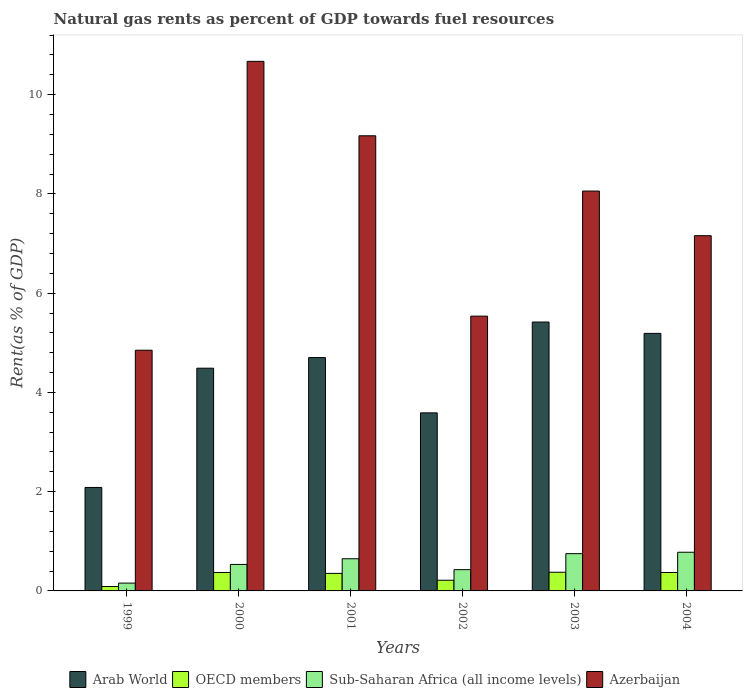How many different coloured bars are there?
Provide a succinct answer. 4. How many groups of bars are there?
Offer a terse response. 6. How many bars are there on the 1st tick from the left?
Ensure brevity in your answer.  4. How many bars are there on the 3rd tick from the right?
Your answer should be compact. 4. In how many cases, is the number of bars for a given year not equal to the number of legend labels?
Your answer should be compact. 0. What is the matural gas rent in Sub-Saharan Africa (all income levels) in 2001?
Make the answer very short. 0.65. Across all years, what is the maximum matural gas rent in Sub-Saharan Africa (all income levels)?
Make the answer very short. 0.78. Across all years, what is the minimum matural gas rent in OECD members?
Make the answer very short. 0.09. In which year was the matural gas rent in Azerbaijan minimum?
Provide a succinct answer. 1999. What is the total matural gas rent in Azerbaijan in the graph?
Offer a very short reply. 45.45. What is the difference between the matural gas rent in Arab World in 2003 and that in 2004?
Provide a succinct answer. 0.23. What is the difference between the matural gas rent in OECD members in 2003 and the matural gas rent in Sub-Saharan Africa (all income levels) in 2004?
Your response must be concise. -0.4. What is the average matural gas rent in Azerbaijan per year?
Offer a very short reply. 7.57. In the year 2003, what is the difference between the matural gas rent in Azerbaijan and matural gas rent in OECD members?
Make the answer very short. 7.68. In how many years, is the matural gas rent in Azerbaijan greater than 9.6 %?
Ensure brevity in your answer.  1. What is the ratio of the matural gas rent in Sub-Saharan Africa (all income levels) in 2001 to that in 2003?
Make the answer very short. 0.86. Is the matural gas rent in Arab World in 1999 less than that in 2004?
Provide a short and direct response. Yes. What is the difference between the highest and the second highest matural gas rent in Azerbaijan?
Offer a very short reply. 1.5. What is the difference between the highest and the lowest matural gas rent in Sub-Saharan Africa (all income levels)?
Make the answer very short. 0.62. In how many years, is the matural gas rent in OECD members greater than the average matural gas rent in OECD members taken over all years?
Make the answer very short. 4. What does the 1st bar from the left in 2002 represents?
Offer a terse response. Arab World. What does the 2nd bar from the right in 2003 represents?
Ensure brevity in your answer.  Sub-Saharan Africa (all income levels). How many bars are there?
Give a very brief answer. 24. What is the difference between two consecutive major ticks on the Y-axis?
Offer a very short reply. 2. Are the values on the major ticks of Y-axis written in scientific E-notation?
Provide a succinct answer. No. Does the graph contain any zero values?
Offer a very short reply. No. Does the graph contain grids?
Your answer should be compact. No. Where does the legend appear in the graph?
Offer a very short reply. Bottom center. How many legend labels are there?
Provide a succinct answer. 4. What is the title of the graph?
Keep it short and to the point. Natural gas rents as percent of GDP towards fuel resources. What is the label or title of the Y-axis?
Offer a very short reply. Rent(as % of GDP). What is the Rent(as % of GDP) in Arab World in 1999?
Your response must be concise. 2.08. What is the Rent(as % of GDP) of OECD members in 1999?
Provide a short and direct response. 0.09. What is the Rent(as % of GDP) of Sub-Saharan Africa (all income levels) in 1999?
Your answer should be very brief. 0.16. What is the Rent(as % of GDP) of Azerbaijan in 1999?
Your response must be concise. 4.85. What is the Rent(as % of GDP) of Arab World in 2000?
Offer a very short reply. 4.49. What is the Rent(as % of GDP) in OECD members in 2000?
Your answer should be very brief. 0.37. What is the Rent(as % of GDP) of Sub-Saharan Africa (all income levels) in 2000?
Give a very brief answer. 0.53. What is the Rent(as % of GDP) of Azerbaijan in 2000?
Your response must be concise. 10.67. What is the Rent(as % of GDP) of Arab World in 2001?
Make the answer very short. 4.7. What is the Rent(as % of GDP) of OECD members in 2001?
Your response must be concise. 0.35. What is the Rent(as % of GDP) of Sub-Saharan Africa (all income levels) in 2001?
Offer a terse response. 0.65. What is the Rent(as % of GDP) in Azerbaijan in 2001?
Make the answer very short. 9.17. What is the Rent(as % of GDP) of Arab World in 2002?
Offer a terse response. 3.59. What is the Rent(as % of GDP) of OECD members in 2002?
Offer a very short reply. 0.22. What is the Rent(as % of GDP) of Sub-Saharan Africa (all income levels) in 2002?
Your answer should be very brief. 0.43. What is the Rent(as % of GDP) in Azerbaijan in 2002?
Your answer should be very brief. 5.54. What is the Rent(as % of GDP) of Arab World in 2003?
Your response must be concise. 5.42. What is the Rent(as % of GDP) of OECD members in 2003?
Your answer should be very brief. 0.38. What is the Rent(as % of GDP) of Sub-Saharan Africa (all income levels) in 2003?
Keep it short and to the point. 0.75. What is the Rent(as % of GDP) of Azerbaijan in 2003?
Provide a short and direct response. 8.06. What is the Rent(as % of GDP) of Arab World in 2004?
Ensure brevity in your answer.  5.19. What is the Rent(as % of GDP) of OECD members in 2004?
Your answer should be compact. 0.37. What is the Rent(as % of GDP) of Sub-Saharan Africa (all income levels) in 2004?
Make the answer very short. 0.78. What is the Rent(as % of GDP) of Azerbaijan in 2004?
Give a very brief answer. 7.16. Across all years, what is the maximum Rent(as % of GDP) in Arab World?
Your response must be concise. 5.42. Across all years, what is the maximum Rent(as % of GDP) of OECD members?
Provide a succinct answer. 0.38. Across all years, what is the maximum Rent(as % of GDP) of Sub-Saharan Africa (all income levels)?
Your response must be concise. 0.78. Across all years, what is the maximum Rent(as % of GDP) of Azerbaijan?
Keep it short and to the point. 10.67. Across all years, what is the minimum Rent(as % of GDP) of Arab World?
Offer a very short reply. 2.08. Across all years, what is the minimum Rent(as % of GDP) of OECD members?
Make the answer very short. 0.09. Across all years, what is the minimum Rent(as % of GDP) in Sub-Saharan Africa (all income levels)?
Your response must be concise. 0.16. Across all years, what is the minimum Rent(as % of GDP) of Azerbaijan?
Provide a succinct answer. 4.85. What is the total Rent(as % of GDP) in Arab World in the graph?
Provide a short and direct response. 25.47. What is the total Rent(as % of GDP) of OECD members in the graph?
Keep it short and to the point. 1.78. What is the total Rent(as % of GDP) in Sub-Saharan Africa (all income levels) in the graph?
Your answer should be compact. 3.3. What is the total Rent(as % of GDP) in Azerbaijan in the graph?
Your answer should be very brief. 45.45. What is the difference between the Rent(as % of GDP) of Arab World in 1999 and that in 2000?
Keep it short and to the point. -2.4. What is the difference between the Rent(as % of GDP) of OECD members in 1999 and that in 2000?
Give a very brief answer. -0.28. What is the difference between the Rent(as % of GDP) of Sub-Saharan Africa (all income levels) in 1999 and that in 2000?
Your answer should be compact. -0.38. What is the difference between the Rent(as % of GDP) in Azerbaijan in 1999 and that in 2000?
Offer a very short reply. -5.82. What is the difference between the Rent(as % of GDP) in Arab World in 1999 and that in 2001?
Give a very brief answer. -2.62. What is the difference between the Rent(as % of GDP) of OECD members in 1999 and that in 2001?
Make the answer very short. -0.26. What is the difference between the Rent(as % of GDP) in Sub-Saharan Africa (all income levels) in 1999 and that in 2001?
Provide a succinct answer. -0.49. What is the difference between the Rent(as % of GDP) in Azerbaijan in 1999 and that in 2001?
Provide a succinct answer. -4.32. What is the difference between the Rent(as % of GDP) of Arab World in 1999 and that in 2002?
Your answer should be very brief. -1.5. What is the difference between the Rent(as % of GDP) of OECD members in 1999 and that in 2002?
Make the answer very short. -0.13. What is the difference between the Rent(as % of GDP) of Sub-Saharan Africa (all income levels) in 1999 and that in 2002?
Your response must be concise. -0.27. What is the difference between the Rent(as % of GDP) in Azerbaijan in 1999 and that in 2002?
Offer a terse response. -0.69. What is the difference between the Rent(as % of GDP) of Arab World in 1999 and that in 2003?
Ensure brevity in your answer.  -3.33. What is the difference between the Rent(as % of GDP) of OECD members in 1999 and that in 2003?
Provide a succinct answer. -0.29. What is the difference between the Rent(as % of GDP) of Sub-Saharan Africa (all income levels) in 1999 and that in 2003?
Provide a succinct answer. -0.59. What is the difference between the Rent(as % of GDP) in Azerbaijan in 1999 and that in 2003?
Ensure brevity in your answer.  -3.21. What is the difference between the Rent(as % of GDP) in Arab World in 1999 and that in 2004?
Your response must be concise. -3.11. What is the difference between the Rent(as % of GDP) in OECD members in 1999 and that in 2004?
Provide a short and direct response. -0.28. What is the difference between the Rent(as % of GDP) of Sub-Saharan Africa (all income levels) in 1999 and that in 2004?
Offer a very short reply. -0.62. What is the difference between the Rent(as % of GDP) of Azerbaijan in 1999 and that in 2004?
Offer a very short reply. -2.31. What is the difference between the Rent(as % of GDP) of Arab World in 2000 and that in 2001?
Your answer should be compact. -0.21. What is the difference between the Rent(as % of GDP) in OECD members in 2000 and that in 2001?
Your answer should be compact. 0.02. What is the difference between the Rent(as % of GDP) in Sub-Saharan Africa (all income levels) in 2000 and that in 2001?
Your answer should be very brief. -0.11. What is the difference between the Rent(as % of GDP) in Azerbaijan in 2000 and that in 2001?
Make the answer very short. 1.5. What is the difference between the Rent(as % of GDP) in Arab World in 2000 and that in 2002?
Offer a terse response. 0.9. What is the difference between the Rent(as % of GDP) in OECD members in 2000 and that in 2002?
Provide a short and direct response. 0.16. What is the difference between the Rent(as % of GDP) in Sub-Saharan Africa (all income levels) in 2000 and that in 2002?
Offer a very short reply. 0.11. What is the difference between the Rent(as % of GDP) in Azerbaijan in 2000 and that in 2002?
Ensure brevity in your answer.  5.13. What is the difference between the Rent(as % of GDP) in Arab World in 2000 and that in 2003?
Your answer should be compact. -0.93. What is the difference between the Rent(as % of GDP) in OECD members in 2000 and that in 2003?
Offer a terse response. -0. What is the difference between the Rent(as % of GDP) of Sub-Saharan Africa (all income levels) in 2000 and that in 2003?
Ensure brevity in your answer.  -0.22. What is the difference between the Rent(as % of GDP) in Azerbaijan in 2000 and that in 2003?
Your answer should be compact. 2.61. What is the difference between the Rent(as % of GDP) in Arab World in 2000 and that in 2004?
Keep it short and to the point. -0.7. What is the difference between the Rent(as % of GDP) of OECD members in 2000 and that in 2004?
Make the answer very short. 0. What is the difference between the Rent(as % of GDP) of Sub-Saharan Africa (all income levels) in 2000 and that in 2004?
Provide a short and direct response. -0.25. What is the difference between the Rent(as % of GDP) in Azerbaijan in 2000 and that in 2004?
Offer a terse response. 3.51. What is the difference between the Rent(as % of GDP) in Arab World in 2001 and that in 2002?
Keep it short and to the point. 1.11. What is the difference between the Rent(as % of GDP) in OECD members in 2001 and that in 2002?
Provide a succinct answer. 0.14. What is the difference between the Rent(as % of GDP) of Sub-Saharan Africa (all income levels) in 2001 and that in 2002?
Your answer should be compact. 0.22. What is the difference between the Rent(as % of GDP) in Azerbaijan in 2001 and that in 2002?
Your response must be concise. 3.63. What is the difference between the Rent(as % of GDP) in Arab World in 2001 and that in 2003?
Provide a short and direct response. -0.72. What is the difference between the Rent(as % of GDP) of OECD members in 2001 and that in 2003?
Ensure brevity in your answer.  -0.02. What is the difference between the Rent(as % of GDP) of Sub-Saharan Africa (all income levels) in 2001 and that in 2003?
Your answer should be compact. -0.1. What is the difference between the Rent(as % of GDP) in Azerbaijan in 2001 and that in 2003?
Your answer should be very brief. 1.11. What is the difference between the Rent(as % of GDP) in Arab World in 2001 and that in 2004?
Make the answer very short. -0.49. What is the difference between the Rent(as % of GDP) of OECD members in 2001 and that in 2004?
Offer a very short reply. -0.02. What is the difference between the Rent(as % of GDP) in Sub-Saharan Africa (all income levels) in 2001 and that in 2004?
Offer a very short reply. -0.13. What is the difference between the Rent(as % of GDP) in Azerbaijan in 2001 and that in 2004?
Give a very brief answer. 2.01. What is the difference between the Rent(as % of GDP) of Arab World in 2002 and that in 2003?
Offer a terse response. -1.83. What is the difference between the Rent(as % of GDP) in OECD members in 2002 and that in 2003?
Your answer should be very brief. -0.16. What is the difference between the Rent(as % of GDP) in Sub-Saharan Africa (all income levels) in 2002 and that in 2003?
Keep it short and to the point. -0.32. What is the difference between the Rent(as % of GDP) in Azerbaijan in 2002 and that in 2003?
Provide a short and direct response. -2.52. What is the difference between the Rent(as % of GDP) in Arab World in 2002 and that in 2004?
Your response must be concise. -1.6. What is the difference between the Rent(as % of GDP) in OECD members in 2002 and that in 2004?
Provide a short and direct response. -0.16. What is the difference between the Rent(as % of GDP) in Sub-Saharan Africa (all income levels) in 2002 and that in 2004?
Your answer should be very brief. -0.35. What is the difference between the Rent(as % of GDP) of Azerbaijan in 2002 and that in 2004?
Give a very brief answer. -1.62. What is the difference between the Rent(as % of GDP) in Arab World in 2003 and that in 2004?
Make the answer very short. 0.23. What is the difference between the Rent(as % of GDP) in OECD members in 2003 and that in 2004?
Your answer should be compact. 0.01. What is the difference between the Rent(as % of GDP) of Sub-Saharan Africa (all income levels) in 2003 and that in 2004?
Give a very brief answer. -0.03. What is the difference between the Rent(as % of GDP) in Azerbaijan in 2003 and that in 2004?
Your answer should be compact. 0.9. What is the difference between the Rent(as % of GDP) of Arab World in 1999 and the Rent(as % of GDP) of OECD members in 2000?
Keep it short and to the point. 1.71. What is the difference between the Rent(as % of GDP) in Arab World in 1999 and the Rent(as % of GDP) in Sub-Saharan Africa (all income levels) in 2000?
Keep it short and to the point. 1.55. What is the difference between the Rent(as % of GDP) of Arab World in 1999 and the Rent(as % of GDP) of Azerbaijan in 2000?
Keep it short and to the point. -8.59. What is the difference between the Rent(as % of GDP) in OECD members in 1999 and the Rent(as % of GDP) in Sub-Saharan Africa (all income levels) in 2000?
Provide a short and direct response. -0.45. What is the difference between the Rent(as % of GDP) of OECD members in 1999 and the Rent(as % of GDP) of Azerbaijan in 2000?
Provide a short and direct response. -10.58. What is the difference between the Rent(as % of GDP) of Sub-Saharan Africa (all income levels) in 1999 and the Rent(as % of GDP) of Azerbaijan in 2000?
Make the answer very short. -10.51. What is the difference between the Rent(as % of GDP) of Arab World in 1999 and the Rent(as % of GDP) of OECD members in 2001?
Your response must be concise. 1.73. What is the difference between the Rent(as % of GDP) in Arab World in 1999 and the Rent(as % of GDP) in Sub-Saharan Africa (all income levels) in 2001?
Provide a short and direct response. 1.44. What is the difference between the Rent(as % of GDP) in Arab World in 1999 and the Rent(as % of GDP) in Azerbaijan in 2001?
Give a very brief answer. -7.09. What is the difference between the Rent(as % of GDP) of OECD members in 1999 and the Rent(as % of GDP) of Sub-Saharan Africa (all income levels) in 2001?
Offer a very short reply. -0.56. What is the difference between the Rent(as % of GDP) in OECD members in 1999 and the Rent(as % of GDP) in Azerbaijan in 2001?
Ensure brevity in your answer.  -9.08. What is the difference between the Rent(as % of GDP) in Sub-Saharan Africa (all income levels) in 1999 and the Rent(as % of GDP) in Azerbaijan in 2001?
Provide a succinct answer. -9.01. What is the difference between the Rent(as % of GDP) in Arab World in 1999 and the Rent(as % of GDP) in OECD members in 2002?
Keep it short and to the point. 1.87. What is the difference between the Rent(as % of GDP) of Arab World in 1999 and the Rent(as % of GDP) of Sub-Saharan Africa (all income levels) in 2002?
Your answer should be very brief. 1.66. What is the difference between the Rent(as % of GDP) of Arab World in 1999 and the Rent(as % of GDP) of Azerbaijan in 2002?
Make the answer very short. -3.45. What is the difference between the Rent(as % of GDP) in OECD members in 1999 and the Rent(as % of GDP) in Sub-Saharan Africa (all income levels) in 2002?
Your response must be concise. -0.34. What is the difference between the Rent(as % of GDP) in OECD members in 1999 and the Rent(as % of GDP) in Azerbaijan in 2002?
Offer a terse response. -5.45. What is the difference between the Rent(as % of GDP) in Sub-Saharan Africa (all income levels) in 1999 and the Rent(as % of GDP) in Azerbaijan in 2002?
Offer a terse response. -5.38. What is the difference between the Rent(as % of GDP) in Arab World in 1999 and the Rent(as % of GDP) in OECD members in 2003?
Ensure brevity in your answer.  1.71. What is the difference between the Rent(as % of GDP) of Arab World in 1999 and the Rent(as % of GDP) of Sub-Saharan Africa (all income levels) in 2003?
Your response must be concise. 1.33. What is the difference between the Rent(as % of GDP) of Arab World in 1999 and the Rent(as % of GDP) of Azerbaijan in 2003?
Keep it short and to the point. -5.97. What is the difference between the Rent(as % of GDP) in OECD members in 1999 and the Rent(as % of GDP) in Sub-Saharan Africa (all income levels) in 2003?
Your answer should be very brief. -0.66. What is the difference between the Rent(as % of GDP) in OECD members in 1999 and the Rent(as % of GDP) in Azerbaijan in 2003?
Keep it short and to the point. -7.97. What is the difference between the Rent(as % of GDP) of Sub-Saharan Africa (all income levels) in 1999 and the Rent(as % of GDP) of Azerbaijan in 2003?
Make the answer very short. -7.9. What is the difference between the Rent(as % of GDP) in Arab World in 1999 and the Rent(as % of GDP) in OECD members in 2004?
Provide a succinct answer. 1.71. What is the difference between the Rent(as % of GDP) of Arab World in 1999 and the Rent(as % of GDP) of Sub-Saharan Africa (all income levels) in 2004?
Make the answer very short. 1.31. What is the difference between the Rent(as % of GDP) of Arab World in 1999 and the Rent(as % of GDP) of Azerbaijan in 2004?
Give a very brief answer. -5.07. What is the difference between the Rent(as % of GDP) in OECD members in 1999 and the Rent(as % of GDP) in Sub-Saharan Africa (all income levels) in 2004?
Your answer should be very brief. -0.69. What is the difference between the Rent(as % of GDP) in OECD members in 1999 and the Rent(as % of GDP) in Azerbaijan in 2004?
Ensure brevity in your answer.  -7.07. What is the difference between the Rent(as % of GDP) in Sub-Saharan Africa (all income levels) in 1999 and the Rent(as % of GDP) in Azerbaijan in 2004?
Give a very brief answer. -7. What is the difference between the Rent(as % of GDP) of Arab World in 2000 and the Rent(as % of GDP) of OECD members in 2001?
Ensure brevity in your answer.  4.13. What is the difference between the Rent(as % of GDP) of Arab World in 2000 and the Rent(as % of GDP) of Sub-Saharan Africa (all income levels) in 2001?
Provide a succinct answer. 3.84. What is the difference between the Rent(as % of GDP) of Arab World in 2000 and the Rent(as % of GDP) of Azerbaijan in 2001?
Make the answer very short. -4.68. What is the difference between the Rent(as % of GDP) in OECD members in 2000 and the Rent(as % of GDP) in Sub-Saharan Africa (all income levels) in 2001?
Ensure brevity in your answer.  -0.28. What is the difference between the Rent(as % of GDP) of OECD members in 2000 and the Rent(as % of GDP) of Azerbaijan in 2001?
Provide a succinct answer. -8.8. What is the difference between the Rent(as % of GDP) in Sub-Saharan Africa (all income levels) in 2000 and the Rent(as % of GDP) in Azerbaijan in 2001?
Offer a terse response. -8.64. What is the difference between the Rent(as % of GDP) of Arab World in 2000 and the Rent(as % of GDP) of OECD members in 2002?
Ensure brevity in your answer.  4.27. What is the difference between the Rent(as % of GDP) in Arab World in 2000 and the Rent(as % of GDP) in Sub-Saharan Africa (all income levels) in 2002?
Make the answer very short. 4.06. What is the difference between the Rent(as % of GDP) in Arab World in 2000 and the Rent(as % of GDP) in Azerbaijan in 2002?
Ensure brevity in your answer.  -1.05. What is the difference between the Rent(as % of GDP) of OECD members in 2000 and the Rent(as % of GDP) of Sub-Saharan Africa (all income levels) in 2002?
Keep it short and to the point. -0.06. What is the difference between the Rent(as % of GDP) in OECD members in 2000 and the Rent(as % of GDP) in Azerbaijan in 2002?
Provide a short and direct response. -5.17. What is the difference between the Rent(as % of GDP) in Sub-Saharan Africa (all income levels) in 2000 and the Rent(as % of GDP) in Azerbaijan in 2002?
Your response must be concise. -5. What is the difference between the Rent(as % of GDP) in Arab World in 2000 and the Rent(as % of GDP) in OECD members in 2003?
Give a very brief answer. 4.11. What is the difference between the Rent(as % of GDP) of Arab World in 2000 and the Rent(as % of GDP) of Sub-Saharan Africa (all income levels) in 2003?
Give a very brief answer. 3.74. What is the difference between the Rent(as % of GDP) in Arab World in 2000 and the Rent(as % of GDP) in Azerbaijan in 2003?
Your response must be concise. -3.57. What is the difference between the Rent(as % of GDP) of OECD members in 2000 and the Rent(as % of GDP) of Sub-Saharan Africa (all income levels) in 2003?
Keep it short and to the point. -0.38. What is the difference between the Rent(as % of GDP) of OECD members in 2000 and the Rent(as % of GDP) of Azerbaijan in 2003?
Your answer should be very brief. -7.69. What is the difference between the Rent(as % of GDP) of Sub-Saharan Africa (all income levels) in 2000 and the Rent(as % of GDP) of Azerbaijan in 2003?
Offer a terse response. -7.52. What is the difference between the Rent(as % of GDP) in Arab World in 2000 and the Rent(as % of GDP) in OECD members in 2004?
Give a very brief answer. 4.12. What is the difference between the Rent(as % of GDP) in Arab World in 2000 and the Rent(as % of GDP) in Sub-Saharan Africa (all income levels) in 2004?
Provide a succinct answer. 3.71. What is the difference between the Rent(as % of GDP) in Arab World in 2000 and the Rent(as % of GDP) in Azerbaijan in 2004?
Your answer should be compact. -2.67. What is the difference between the Rent(as % of GDP) in OECD members in 2000 and the Rent(as % of GDP) in Sub-Saharan Africa (all income levels) in 2004?
Make the answer very short. -0.41. What is the difference between the Rent(as % of GDP) in OECD members in 2000 and the Rent(as % of GDP) in Azerbaijan in 2004?
Keep it short and to the point. -6.79. What is the difference between the Rent(as % of GDP) of Sub-Saharan Africa (all income levels) in 2000 and the Rent(as % of GDP) of Azerbaijan in 2004?
Provide a succinct answer. -6.62. What is the difference between the Rent(as % of GDP) in Arab World in 2001 and the Rent(as % of GDP) in OECD members in 2002?
Your answer should be very brief. 4.49. What is the difference between the Rent(as % of GDP) in Arab World in 2001 and the Rent(as % of GDP) in Sub-Saharan Africa (all income levels) in 2002?
Your answer should be very brief. 4.27. What is the difference between the Rent(as % of GDP) of Arab World in 2001 and the Rent(as % of GDP) of Azerbaijan in 2002?
Your response must be concise. -0.84. What is the difference between the Rent(as % of GDP) of OECD members in 2001 and the Rent(as % of GDP) of Sub-Saharan Africa (all income levels) in 2002?
Offer a very short reply. -0.08. What is the difference between the Rent(as % of GDP) in OECD members in 2001 and the Rent(as % of GDP) in Azerbaijan in 2002?
Your answer should be very brief. -5.18. What is the difference between the Rent(as % of GDP) of Sub-Saharan Africa (all income levels) in 2001 and the Rent(as % of GDP) of Azerbaijan in 2002?
Give a very brief answer. -4.89. What is the difference between the Rent(as % of GDP) of Arab World in 2001 and the Rent(as % of GDP) of OECD members in 2003?
Your response must be concise. 4.33. What is the difference between the Rent(as % of GDP) in Arab World in 2001 and the Rent(as % of GDP) in Sub-Saharan Africa (all income levels) in 2003?
Your answer should be very brief. 3.95. What is the difference between the Rent(as % of GDP) in Arab World in 2001 and the Rent(as % of GDP) in Azerbaijan in 2003?
Make the answer very short. -3.36. What is the difference between the Rent(as % of GDP) of OECD members in 2001 and the Rent(as % of GDP) of Sub-Saharan Africa (all income levels) in 2003?
Give a very brief answer. -0.4. What is the difference between the Rent(as % of GDP) in OECD members in 2001 and the Rent(as % of GDP) in Azerbaijan in 2003?
Make the answer very short. -7.7. What is the difference between the Rent(as % of GDP) in Sub-Saharan Africa (all income levels) in 2001 and the Rent(as % of GDP) in Azerbaijan in 2003?
Offer a very short reply. -7.41. What is the difference between the Rent(as % of GDP) of Arab World in 2001 and the Rent(as % of GDP) of OECD members in 2004?
Keep it short and to the point. 4.33. What is the difference between the Rent(as % of GDP) of Arab World in 2001 and the Rent(as % of GDP) of Sub-Saharan Africa (all income levels) in 2004?
Your answer should be very brief. 3.92. What is the difference between the Rent(as % of GDP) in Arab World in 2001 and the Rent(as % of GDP) in Azerbaijan in 2004?
Your answer should be compact. -2.46. What is the difference between the Rent(as % of GDP) in OECD members in 2001 and the Rent(as % of GDP) in Sub-Saharan Africa (all income levels) in 2004?
Offer a very short reply. -0.43. What is the difference between the Rent(as % of GDP) of OECD members in 2001 and the Rent(as % of GDP) of Azerbaijan in 2004?
Your answer should be very brief. -6.81. What is the difference between the Rent(as % of GDP) of Sub-Saharan Africa (all income levels) in 2001 and the Rent(as % of GDP) of Azerbaijan in 2004?
Give a very brief answer. -6.51. What is the difference between the Rent(as % of GDP) of Arab World in 2002 and the Rent(as % of GDP) of OECD members in 2003?
Provide a short and direct response. 3.21. What is the difference between the Rent(as % of GDP) in Arab World in 2002 and the Rent(as % of GDP) in Sub-Saharan Africa (all income levels) in 2003?
Your answer should be very brief. 2.84. What is the difference between the Rent(as % of GDP) of Arab World in 2002 and the Rent(as % of GDP) of Azerbaijan in 2003?
Provide a short and direct response. -4.47. What is the difference between the Rent(as % of GDP) in OECD members in 2002 and the Rent(as % of GDP) in Sub-Saharan Africa (all income levels) in 2003?
Provide a succinct answer. -0.54. What is the difference between the Rent(as % of GDP) in OECD members in 2002 and the Rent(as % of GDP) in Azerbaijan in 2003?
Make the answer very short. -7.84. What is the difference between the Rent(as % of GDP) of Sub-Saharan Africa (all income levels) in 2002 and the Rent(as % of GDP) of Azerbaijan in 2003?
Make the answer very short. -7.63. What is the difference between the Rent(as % of GDP) in Arab World in 2002 and the Rent(as % of GDP) in OECD members in 2004?
Keep it short and to the point. 3.22. What is the difference between the Rent(as % of GDP) of Arab World in 2002 and the Rent(as % of GDP) of Sub-Saharan Africa (all income levels) in 2004?
Make the answer very short. 2.81. What is the difference between the Rent(as % of GDP) of Arab World in 2002 and the Rent(as % of GDP) of Azerbaijan in 2004?
Give a very brief answer. -3.57. What is the difference between the Rent(as % of GDP) in OECD members in 2002 and the Rent(as % of GDP) in Sub-Saharan Africa (all income levels) in 2004?
Provide a succinct answer. -0.56. What is the difference between the Rent(as % of GDP) in OECD members in 2002 and the Rent(as % of GDP) in Azerbaijan in 2004?
Your answer should be very brief. -6.94. What is the difference between the Rent(as % of GDP) in Sub-Saharan Africa (all income levels) in 2002 and the Rent(as % of GDP) in Azerbaijan in 2004?
Provide a succinct answer. -6.73. What is the difference between the Rent(as % of GDP) of Arab World in 2003 and the Rent(as % of GDP) of OECD members in 2004?
Provide a succinct answer. 5.05. What is the difference between the Rent(as % of GDP) in Arab World in 2003 and the Rent(as % of GDP) in Sub-Saharan Africa (all income levels) in 2004?
Give a very brief answer. 4.64. What is the difference between the Rent(as % of GDP) of Arab World in 2003 and the Rent(as % of GDP) of Azerbaijan in 2004?
Make the answer very short. -1.74. What is the difference between the Rent(as % of GDP) in OECD members in 2003 and the Rent(as % of GDP) in Sub-Saharan Africa (all income levels) in 2004?
Your response must be concise. -0.4. What is the difference between the Rent(as % of GDP) of OECD members in 2003 and the Rent(as % of GDP) of Azerbaijan in 2004?
Your response must be concise. -6.78. What is the difference between the Rent(as % of GDP) in Sub-Saharan Africa (all income levels) in 2003 and the Rent(as % of GDP) in Azerbaijan in 2004?
Offer a very short reply. -6.41. What is the average Rent(as % of GDP) in Arab World per year?
Give a very brief answer. 4.25. What is the average Rent(as % of GDP) in OECD members per year?
Ensure brevity in your answer.  0.3. What is the average Rent(as % of GDP) of Sub-Saharan Africa (all income levels) per year?
Make the answer very short. 0.55. What is the average Rent(as % of GDP) of Azerbaijan per year?
Your response must be concise. 7.57. In the year 1999, what is the difference between the Rent(as % of GDP) in Arab World and Rent(as % of GDP) in OECD members?
Provide a short and direct response. 2. In the year 1999, what is the difference between the Rent(as % of GDP) of Arab World and Rent(as % of GDP) of Sub-Saharan Africa (all income levels)?
Offer a terse response. 1.93. In the year 1999, what is the difference between the Rent(as % of GDP) in Arab World and Rent(as % of GDP) in Azerbaijan?
Your answer should be very brief. -2.77. In the year 1999, what is the difference between the Rent(as % of GDP) of OECD members and Rent(as % of GDP) of Sub-Saharan Africa (all income levels)?
Your answer should be compact. -0.07. In the year 1999, what is the difference between the Rent(as % of GDP) in OECD members and Rent(as % of GDP) in Azerbaijan?
Your answer should be very brief. -4.76. In the year 1999, what is the difference between the Rent(as % of GDP) of Sub-Saharan Africa (all income levels) and Rent(as % of GDP) of Azerbaijan?
Ensure brevity in your answer.  -4.69. In the year 2000, what is the difference between the Rent(as % of GDP) in Arab World and Rent(as % of GDP) in OECD members?
Ensure brevity in your answer.  4.12. In the year 2000, what is the difference between the Rent(as % of GDP) of Arab World and Rent(as % of GDP) of Sub-Saharan Africa (all income levels)?
Provide a short and direct response. 3.95. In the year 2000, what is the difference between the Rent(as % of GDP) of Arab World and Rent(as % of GDP) of Azerbaijan?
Give a very brief answer. -6.18. In the year 2000, what is the difference between the Rent(as % of GDP) in OECD members and Rent(as % of GDP) in Sub-Saharan Africa (all income levels)?
Your response must be concise. -0.16. In the year 2000, what is the difference between the Rent(as % of GDP) in OECD members and Rent(as % of GDP) in Azerbaijan?
Offer a very short reply. -10.3. In the year 2000, what is the difference between the Rent(as % of GDP) in Sub-Saharan Africa (all income levels) and Rent(as % of GDP) in Azerbaijan?
Offer a terse response. -10.14. In the year 2001, what is the difference between the Rent(as % of GDP) in Arab World and Rent(as % of GDP) in OECD members?
Your answer should be compact. 4.35. In the year 2001, what is the difference between the Rent(as % of GDP) in Arab World and Rent(as % of GDP) in Sub-Saharan Africa (all income levels)?
Provide a short and direct response. 4.05. In the year 2001, what is the difference between the Rent(as % of GDP) of Arab World and Rent(as % of GDP) of Azerbaijan?
Provide a succinct answer. -4.47. In the year 2001, what is the difference between the Rent(as % of GDP) of OECD members and Rent(as % of GDP) of Sub-Saharan Africa (all income levels)?
Your response must be concise. -0.29. In the year 2001, what is the difference between the Rent(as % of GDP) in OECD members and Rent(as % of GDP) in Azerbaijan?
Offer a very short reply. -8.82. In the year 2001, what is the difference between the Rent(as % of GDP) in Sub-Saharan Africa (all income levels) and Rent(as % of GDP) in Azerbaijan?
Offer a very short reply. -8.52. In the year 2002, what is the difference between the Rent(as % of GDP) in Arab World and Rent(as % of GDP) in OECD members?
Make the answer very short. 3.37. In the year 2002, what is the difference between the Rent(as % of GDP) in Arab World and Rent(as % of GDP) in Sub-Saharan Africa (all income levels)?
Your response must be concise. 3.16. In the year 2002, what is the difference between the Rent(as % of GDP) in Arab World and Rent(as % of GDP) in Azerbaijan?
Give a very brief answer. -1.95. In the year 2002, what is the difference between the Rent(as % of GDP) in OECD members and Rent(as % of GDP) in Sub-Saharan Africa (all income levels)?
Offer a terse response. -0.21. In the year 2002, what is the difference between the Rent(as % of GDP) in OECD members and Rent(as % of GDP) in Azerbaijan?
Make the answer very short. -5.32. In the year 2002, what is the difference between the Rent(as % of GDP) of Sub-Saharan Africa (all income levels) and Rent(as % of GDP) of Azerbaijan?
Provide a succinct answer. -5.11. In the year 2003, what is the difference between the Rent(as % of GDP) of Arab World and Rent(as % of GDP) of OECD members?
Make the answer very short. 5.04. In the year 2003, what is the difference between the Rent(as % of GDP) of Arab World and Rent(as % of GDP) of Sub-Saharan Africa (all income levels)?
Provide a succinct answer. 4.67. In the year 2003, what is the difference between the Rent(as % of GDP) in Arab World and Rent(as % of GDP) in Azerbaijan?
Your answer should be compact. -2.64. In the year 2003, what is the difference between the Rent(as % of GDP) in OECD members and Rent(as % of GDP) in Sub-Saharan Africa (all income levels)?
Provide a succinct answer. -0.37. In the year 2003, what is the difference between the Rent(as % of GDP) in OECD members and Rent(as % of GDP) in Azerbaijan?
Your response must be concise. -7.68. In the year 2003, what is the difference between the Rent(as % of GDP) of Sub-Saharan Africa (all income levels) and Rent(as % of GDP) of Azerbaijan?
Provide a short and direct response. -7.31. In the year 2004, what is the difference between the Rent(as % of GDP) in Arab World and Rent(as % of GDP) in OECD members?
Provide a short and direct response. 4.82. In the year 2004, what is the difference between the Rent(as % of GDP) of Arab World and Rent(as % of GDP) of Sub-Saharan Africa (all income levels)?
Your answer should be compact. 4.41. In the year 2004, what is the difference between the Rent(as % of GDP) in Arab World and Rent(as % of GDP) in Azerbaijan?
Offer a terse response. -1.97. In the year 2004, what is the difference between the Rent(as % of GDP) in OECD members and Rent(as % of GDP) in Sub-Saharan Africa (all income levels)?
Provide a short and direct response. -0.41. In the year 2004, what is the difference between the Rent(as % of GDP) of OECD members and Rent(as % of GDP) of Azerbaijan?
Keep it short and to the point. -6.79. In the year 2004, what is the difference between the Rent(as % of GDP) in Sub-Saharan Africa (all income levels) and Rent(as % of GDP) in Azerbaijan?
Keep it short and to the point. -6.38. What is the ratio of the Rent(as % of GDP) of Arab World in 1999 to that in 2000?
Keep it short and to the point. 0.46. What is the ratio of the Rent(as % of GDP) of OECD members in 1999 to that in 2000?
Offer a terse response. 0.24. What is the ratio of the Rent(as % of GDP) in Sub-Saharan Africa (all income levels) in 1999 to that in 2000?
Your answer should be compact. 0.29. What is the ratio of the Rent(as % of GDP) in Azerbaijan in 1999 to that in 2000?
Your answer should be very brief. 0.45. What is the ratio of the Rent(as % of GDP) in Arab World in 1999 to that in 2001?
Your answer should be compact. 0.44. What is the ratio of the Rent(as % of GDP) in OECD members in 1999 to that in 2001?
Make the answer very short. 0.25. What is the ratio of the Rent(as % of GDP) of Sub-Saharan Africa (all income levels) in 1999 to that in 2001?
Keep it short and to the point. 0.24. What is the ratio of the Rent(as % of GDP) of Azerbaijan in 1999 to that in 2001?
Keep it short and to the point. 0.53. What is the ratio of the Rent(as % of GDP) in Arab World in 1999 to that in 2002?
Your answer should be very brief. 0.58. What is the ratio of the Rent(as % of GDP) in OECD members in 1999 to that in 2002?
Offer a very short reply. 0.41. What is the ratio of the Rent(as % of GDP) in Sub-Saharan Africa (all income levels) in 1999 to that in 2002?
Your answer should be very brief. 0.37. What is the ratio of the Rent(as % of GDP) in Azerbaijan in 1999 to that in 2002?
Keep it short and to the point. 0.88. What is the ratio of the Rent(as % of GDP) in Arab World in 1999 to that in 2003?
Provide a succinct answer. 0.38. What is the ratio of the Rent(as % of GDP) in OECD members in 1999 to that in 2003?
Keep it short and to the point. 0.24. What is the ratio of the Rent(as % of GDP) in Sub-Saharan Africa (all income levels) in 1999 to that in 2003?
Your answer should be compact. 0.21. What is the ratio of the Rent(as % of GDP) of Azerbaijan in 1999 to that in 2003?
Your answer should be compact. 0.6. What is the ratio of the Rent(as % of GDP) in Arab World in 1999 to that in 2004?
Your answer should be compact. 0.4. What is the ratio of the Rent(as % of GDP) in OECD members in 1999 to that in 2004?
Your response must be concise. 0.24. What is the ratio of the Rent(as % of GDP) in Sub-Saharan Africa (all income levels) in 1999 to that in 2004?
Make the answer very short. 0.2. What is the ratio of the Rent(as % of GDP) in Azerbaijan in 1999 to that in 2004?
Your response must be concise. 0.68. What is the ratio of the Rent(as % of GDP) of Arab World in 2000 to that in 2001?
Offer a very short reply. 0.95. What is the ratio of the Rent(as % of GDP) of OECD members in 2000 to that in 2001?
Your response must be concise. 1.05. What is the ratio of the Rent(as % of GDP) of Sub-Saharan Africa (all income levels) in 2000 to that in 2001?
Keep it short and to the point. 0.82. What is the ratio of the Rent(as % of GDP) of Azerbaijan in 2000 to that in 2001?
Your response must be concise. 1.16. What is the ratio of the Rent(as % of GDP) in Arab World in 2000 to that in 2002?
Your answer should be compact. 1.25. What is the ratio of the Rent(as % of GDP) in OECD members in 2000 to that in 2002?
Your answer should be compact. 1.73. What is the ratio of the Rent(as % of GDP) of Sub-Saharan Africa (all income levels) in 2000 to that in 2002?
Provide a short and direct response. 1.25. What is the ratio of the Rent(as % of GDP) in Azerbaijan in 2000 to that in 2002?
Provide a succinct answer. 1.93. What is the ratio of the Rent(as % of GDP) of Arab World in 2000 to that in 2003?
Offer a terse response. 0.83. What is the ratio of the Rent(as % of GDP) in OECD members in 2000 to that in 2003?
Offer a terse response. 0.99. What is the ratio of the Rent(as % of GDP) in Sub-Saharan Africa (all income levels) in 2000 to that in 2003?
Provide a succinct answer. 0.71. What is the ratio of the Rent(as % of GDP) in Azerbaijan in 2000 to that in 2003?
Your answer should be compact. 1.32. What is the ratio of the Rent(as % of GDP) of Arab World in 2000 to that in 2004?
Give a very brief answer. 0.86. What is the ratio of the Rent(as % of GDP) in Sub-Saharan Africa (all income levels) in 2000 to that in 2004?
Your answer should be very brief. 0.69. What is the ratio of the Rent(as % of GDP) in Azerbaijan in 2000 to that in 2004?
Offer a very short reply. 1.49. What is the ratio of the Rent(as % of GDP) in Arab World in 2001 to that in 2002?
Provide a short and direct response. 1.31. What is the ratio of the Rent(as % of GDP) in OECD members in 2001 to that in 2002?
Ensure brevity in your answer.  1.64. What is the ratio of the Rent(as % of GDP) of Sub-Saharan Africa (all income levels) in 2001 to that in 2002?
Ensure brevity in your answer.  1.51. What is the ratio of the Rent(as % of GDP) in Azerbaijan in 2001 to that in 2002?
Your answer should be very brief. 1.66. What is the ratio of the Rent(as % of GDP) in Arab World in 2001 to that in 2003?
Make the answer very short. 0.87. What is the ratio of the Rent(as % of GDP) in OECD members in 2001 to that in 2003?
Provide a short and direct response. 0.94. What is the ratio of the Rent(as % of GDP) of Sub-Saharan Africa (all income levels) in 2001 to that in 2003?
Provide a short and direct response. 0.86. What is the ratio of the Rent(as % of GDP) of Azerbaijan in 2001 to that in 2003?
Provide a succinct answer. 1.14. What is the ratio of the Rent(as % of GDP) in Arab World in 2001 to that in 2004?
Your answer should be very brief. 0.91. What is the ratio of the Rent(as % of GDP) of OECD members in 2001 to that in 2004?
Ensure brevity in your answer.  0.95. What is the ratio of the Rent(as % of GDP) in Sub-Saharan Africa (all income levels) in 2001 to that in 2004?
Offer a very short reply. 0.83. What is the ratio of the Rent(as % of GDP) of Azerbaijan in 2001 to that in 2004?
Offer a very short reply. 1.28. What is the ratio of the Rent(as % of GDP) of Arab World in 2002 to that in 2003?
Provide a succinct answer. 0.66. What is the ratio of the Rent(as % of GDP) of OECD members in 2002 to that in 2003?
Provide a succinct answer. 0.57. What is the ratio of the Rent(as % of GDP) in Sub-Saharan Africa (all income levels) in 2002 to that in 2003?
Your answer should be very brief. 0.57. What is the ratio of the Rent(as % of GDP) in Azerbaijan in 2002 to that in 2003?
Provide a succinct answer. 0.69. What is the ratio of the Rent(as % of GDP) in Arab World in 2002 to that in 2004?
Keep it short and to the point. 0.69. What is the ratio of the Rent(as % of GDP) in OECD members in 2002 to that in 2004?
Ensure brevity in your answer.  0.58. What is the ratio of the Rent(as % of GDP) of Sub-Saharan Africa (all income levels) in 2002 to that in 2004?
Your answer should be compact. 0.55. What is the ratio of the Rent(as % of GDP) of Azerbaijan in 2002 to that in 2004?
Give a very brief answer. 0.77. What is the ratio of the Rent(as % of GDP) of Arab World in 2003 to that in 2004?
Your answer should be very brief. 1.04. What is the ratio of the Rent(as % of GDP) in OECD members in 2003 to that in 2004?
Give a very brief answer. 1.01. What is the ratio of the Rent(as % of GDP) in Sub-Saharan Africa (all income levels) in 2003 to that in 2004?
Provide a short and direct response. 0.96. What is the ratio of the Rent(as % of GDP) in Azerbaijan in 2003 to that in 2004?
Provide a succinct answer. 1.13. What is the difference between the highest and the second highest Rent(as % of GDP) of Arab World?
Make the answer very short. 0.23. What is the difference between the highest and the second highest Rent(as % of GDP) in OECD members?
Your answer should be very brief. 0. What is the difference between the highest and the second highest Rent(as % of GDP) of Sub-Saharan Africa (all income levels)?
Your answer should be compact. 0.03. What is the difference between the highest and the second highest Rent(as % of GDP) in Azerbaijan?
Offer a very short reply. 1.5. What is the difference between the highest and the lowest Rent(as % of GDP) in Arab World?
Your answer should be compact. 3.33. What is the difference between the highest and the lowest Rent(as % of GDP) in OECD members?
Give a very brief answer. 0.29. What is the difference between the highest and the lowest Rent(as % of GDP) in Sub-Saharan Africa (all income levels)?
Your answer should be compact. 0.62. What is the difference between the highest and the lowest Rent(as % of GDP) in Azerbaijan?
Provide a succinct answer. 5.82. 